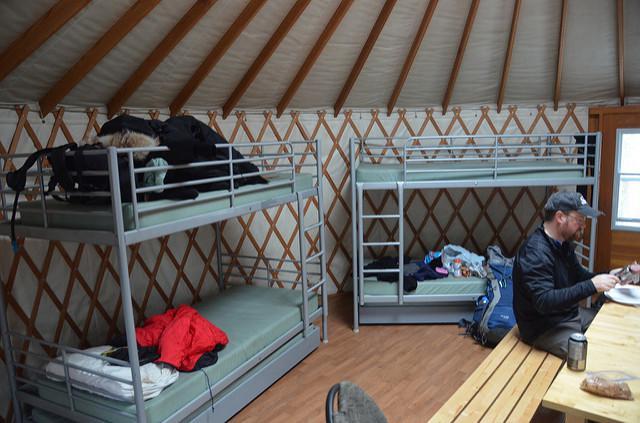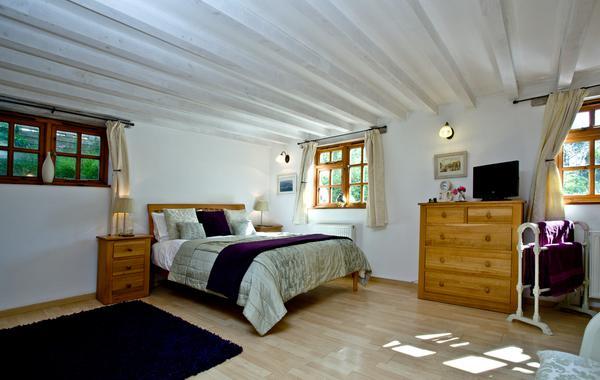The first image is the image on the left, the second image is the image on the right. Evaluate the accuracy of this statement regarding the images: "The door opens to the living area of the yurt in one of the images.". Is it true? Answer yes or no. No. The first image is the image on the left, the second image is the image on the right. Analyze the images presented: Is the assertion "Left and right images feature a bedroom inside a yurt, and at least one bedroom features a bed flanked by wooden nightstands." valid? Answer yes or no. Yes. 